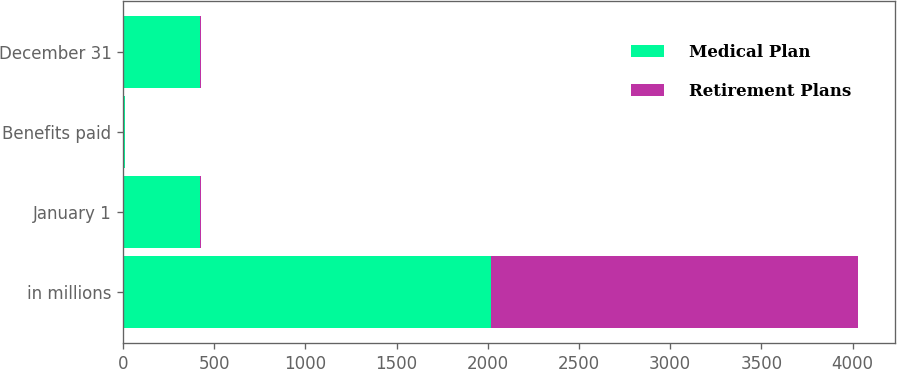<chart> <loc_0><loc_0><loc_500><loc_500><stacked_bar_chart><ecel><fcel>in millions<fcel>January 1<fcel>Benefits paid<fcel>December 31<nl><fcel>Medical Plan<fcel>2015<fcel>420.6<fcel>11.1<fcel>422.7<nl><fcel>Retirement Plans<fcel>2015<fcel>7.2<fcel>1.9<fcel>5.7<nl></chart> 